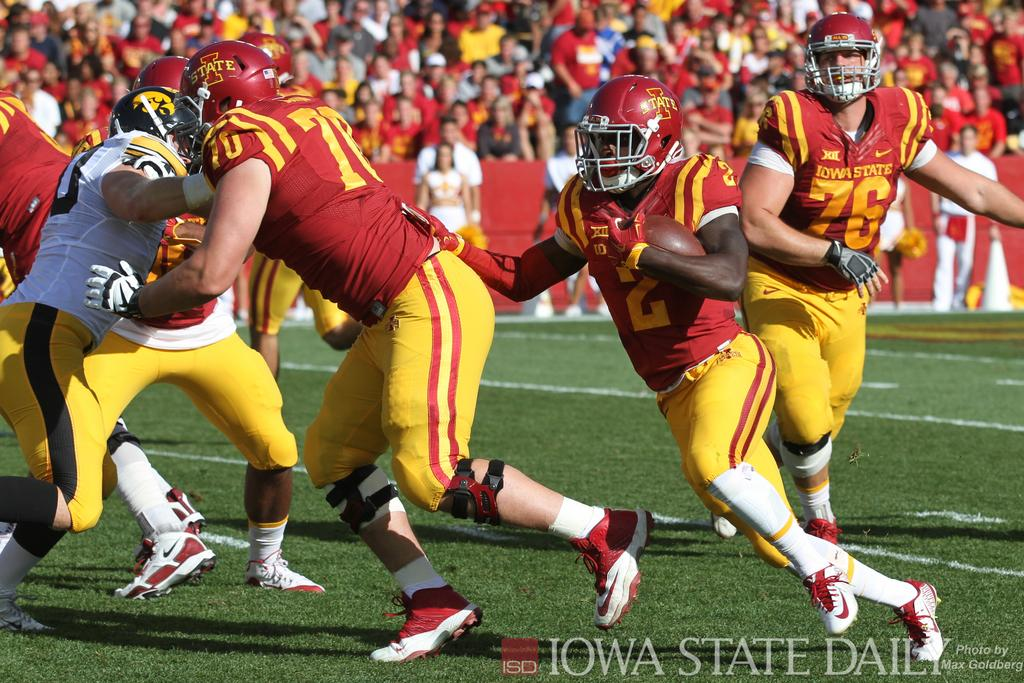What are the people in the image doing? The persons in the image are on the grass in the center of the image. What can be seen in the background of the image? There is a crowd and fencing in the background of the image, along with grass. How many tickets are visible in the image? There are no tickets present in the image. What type of bikes can be seen in the image? There are no bikes present in the image. 